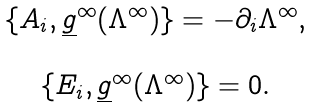<formula> <loc_0><loc_0><loc_500><loc_500>\begin{array} { c } \{ A _ { i } , \underline { g } ^ { \infty } ( \Lambda ^ { \infty } ) \} = - \partial _ { i } \Lambda ^ { \infty } , \\ \\ \{ E _ { i } , \underline { g } ^ { \infty } ( \Lambda ^ { \infty } ) \} = 0 . \end{array}</formula> 